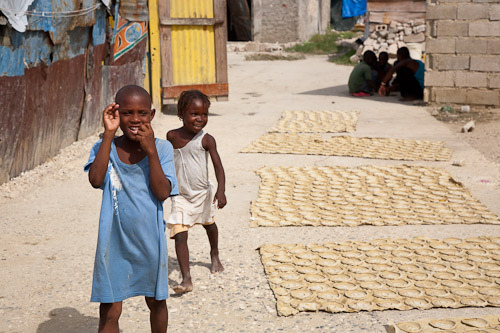<image>
Is the man next to the little girl? No. The man is not positioned next to the little girl. They are located in different areas of the scene. Is there a boy to the left of the girl? No. The boy is not to the left of the girl. From this viewpoint, they have a different horizontal relationship. 